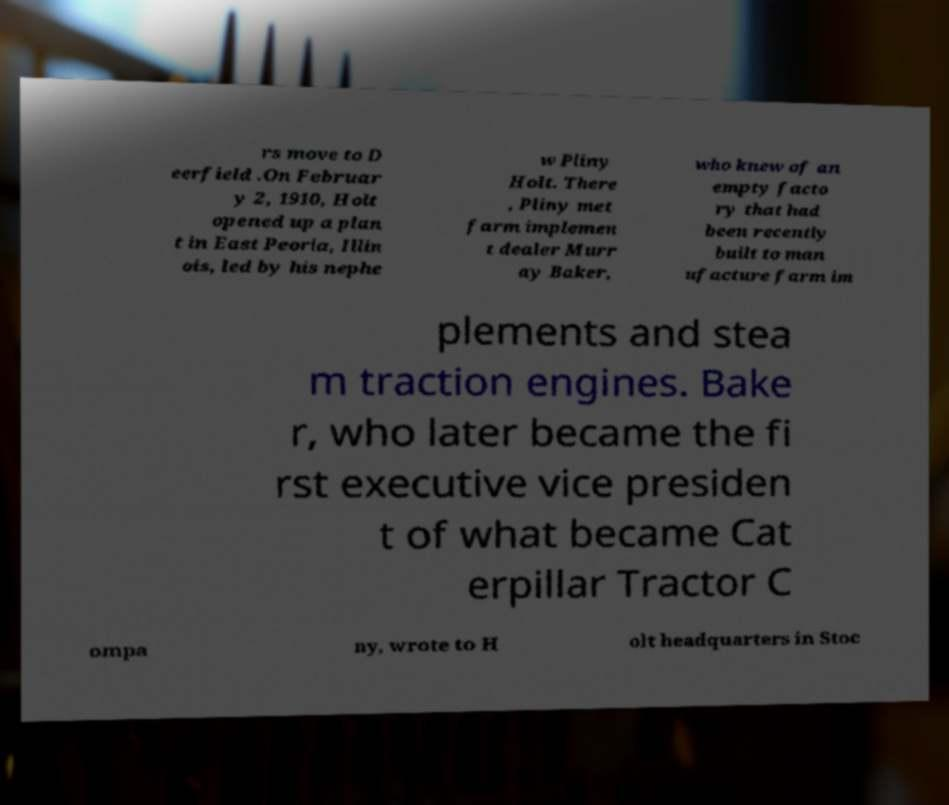There's text embedded in this image that I need extracted. Can you transcribe it verbatim? rs move to D eerfield .On Februar y 2, 1910, Holt opened up a plan t in East Peoria, Illin ois, led by his nephe w Pliny Holt. There , Pliny met farm implemen t dealer Murr ay Baker, who knew of an empty facto ry that had been recently built to man ufacture farm im plements and stea m traction engines. Bake r, who later became the fi rst executive vice presiden t of what became Cat erpillar Tractor C ompa ny, wrote to H olt headquarters in Stoc 